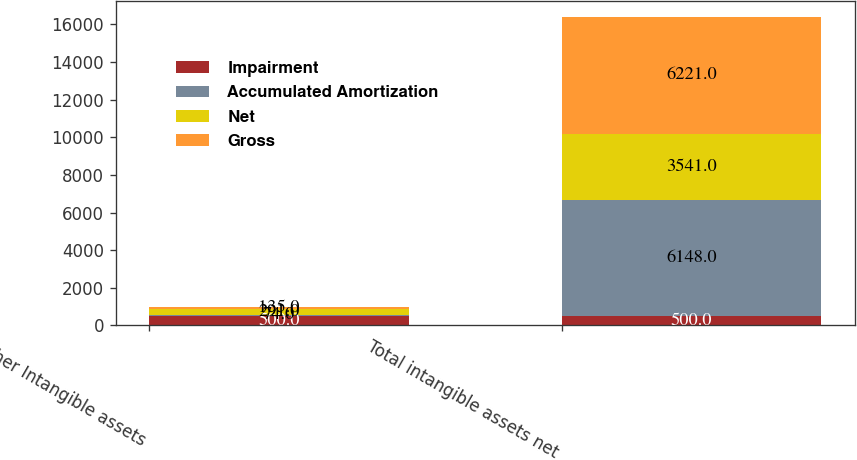<chart> <loc_0><loc_0><loc_500><loc_500><stacked_bar_chart><ecel><fcel>Other Intangible assets<fcel>Total intangible assets net<nl><fcel>Impairment<fcel>500<fcel>500<nl><fcel>Accumulated Amortization<fcel>74<fcel>6148<nl><fcel>Net<fcel>291<fcel>3541<nl><fcel>Gross<fcel>135<fcel>6221<nl></chart> 